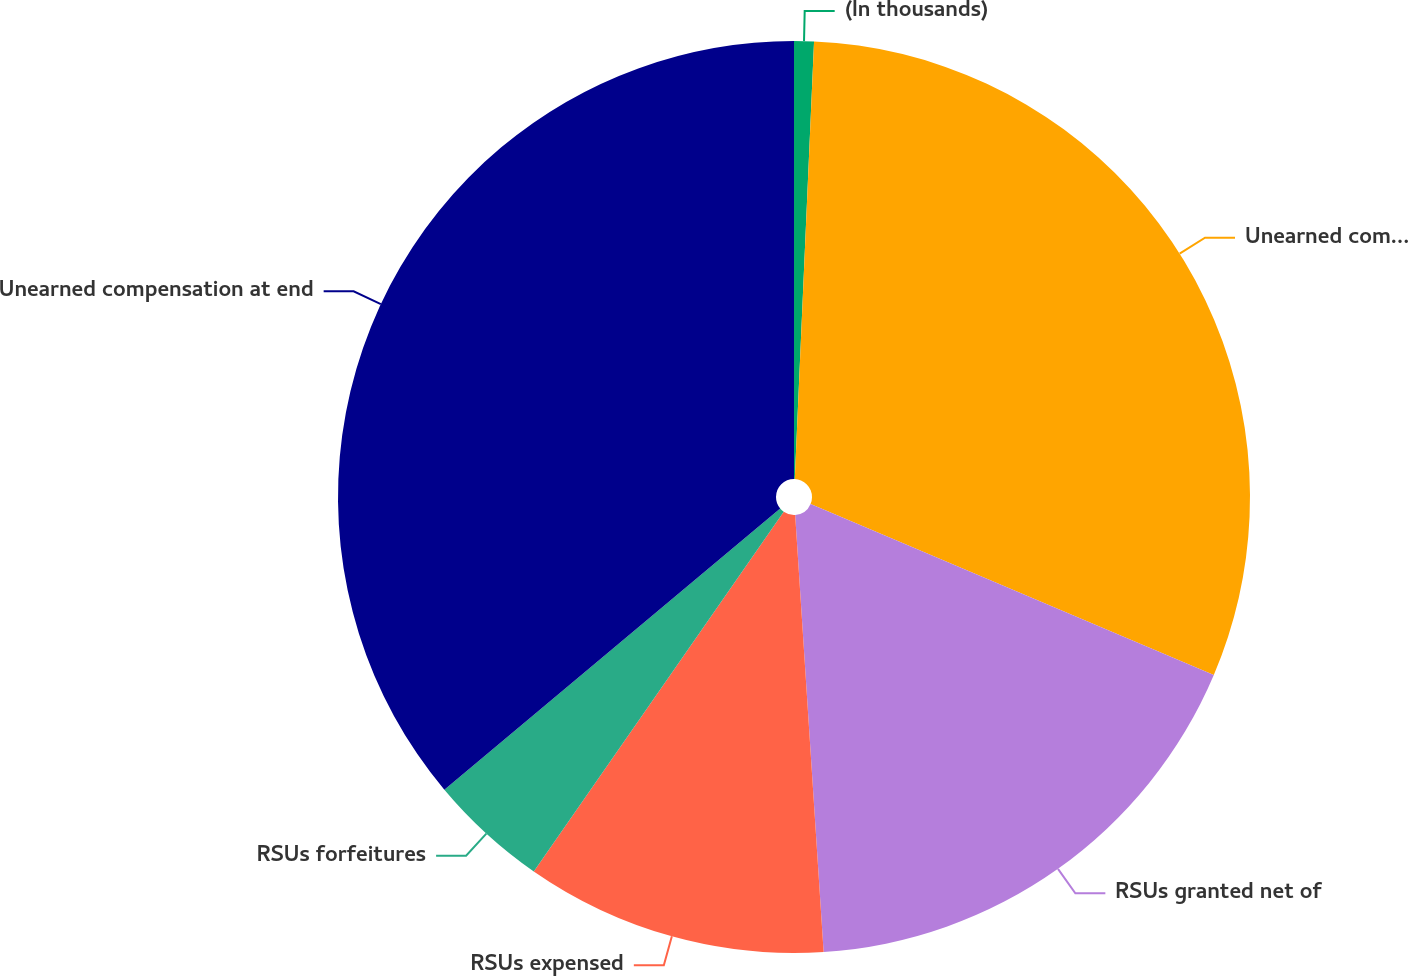Convert chart. <chart><loc_0><loc_0><loc_500><loc_500><pie_chart><fcel>(In thousands)<fcel>Unearned compensation at<fcel>RSUs granted net of<fcel>RSUs expensed<fcel>RSUs forfeitures<fcel>Unearned compensation at end<nl><fcel>0.7%<fcel>30.68%<fcel>17.58%<fcel>10.7%<fcel>4.24%<fcel>36.09%<nl></chart> 